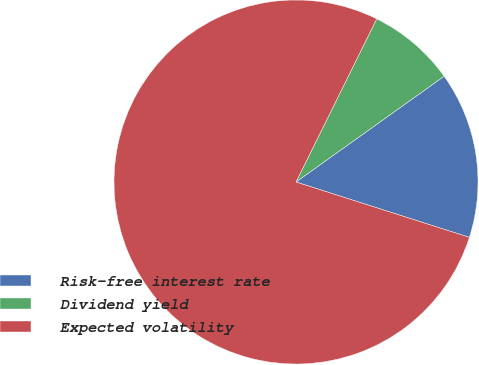<chart> <loc_0><loc_0><loc_500><loc_500><pie_chart><fcel>Risk-free interest rate<fcel>Dividend yield<fcel>Expected volatility<nl><fcel>14.79%<fcel>7.82%<fcel>77.39%<nl></chart> 